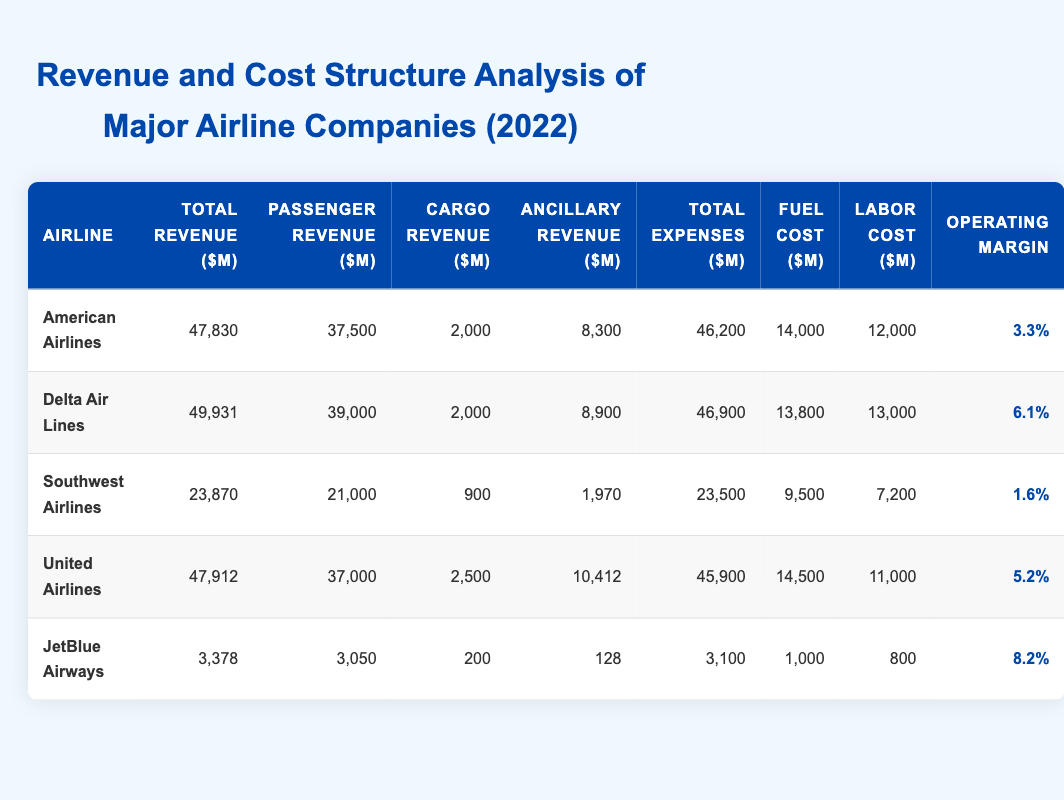What is the total revenue for Delta Air Lines? The table shows that Delta Air Lines has a total revenue of 49,931 million dollars.
Answer: 49,931 million dollars Which airline has the highest operating margin? By examining the operating margin column, JetBlue Airways has the highest operating margin at 8.2%.
Answer: JetBlue Airways What is the total passenger revenue of all airlines combined? The total passenger revenues for each airline are: 37,500 + 39,000 + 21,000 + 37,000 + 3,050 = 137,550 million dollars.
Answer: 137,550 million dollars Is American Airlines' fuel cost greater than its labor cost? American Airlines has a fuel cost of 14,000 million and a labor cost of 12,000 million. Since 14,000 > 12,000, the statement is true.
Answer: Yes What is the difference in total expenses between Southwest Airlines and JetBlue Airways? Southwest Airlines has total expenses of 23,500 million and JetBlue Airways has total expenses of 3,100 million. The difference is 23,500 - 3,100 = 20,400 million dollars.
Answer: 20,400 million dollars How much of the total revenue for United Airlines comes from ancillary revenue? United Airlines has a total revenue of 47,912 million and ancillary revenue of 10,412 million. Therefore, the proportion coming from ancillary revenue is 10,412 / 47,912 = 0.217 or 21.7%.
Answer: 21.7% Which airline reported the lowest total revenue? JetBlue Airways reported the lowest total revenue at 3,378 million dollars, compared to the others in the table.
Answer: JetBlue Airways What is the average fuel cost among these airlines? The fuel costs are: 14,000 (American) + 13,800 (Delta) + 9,500 (Southwest) + 14,500 (United) + 1,000 (JetBlue) = 52,800 million. Dividing by 5 airlines gives an average of 52,800 / 5 = 10,560 million dollars.
Answer: 10,560 million dollars 